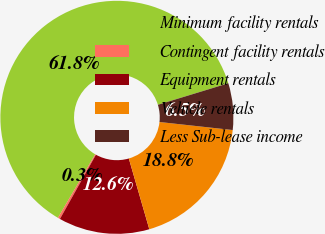Convert chart. <chart><loc_0><loc_0><loc_500><loc_500><pie_chart><fcel>Minimum facility rentals<fcel>Contingent facility rentals<fcel>Equipment rentals<fcel>Vehicle rentals<fcel>Less Sub-lease income<nl><fcel>61.84%<fcel>0.31%<fcel>12.62%<fcel>18.77%<fcel>6.46%<nl></chart> 